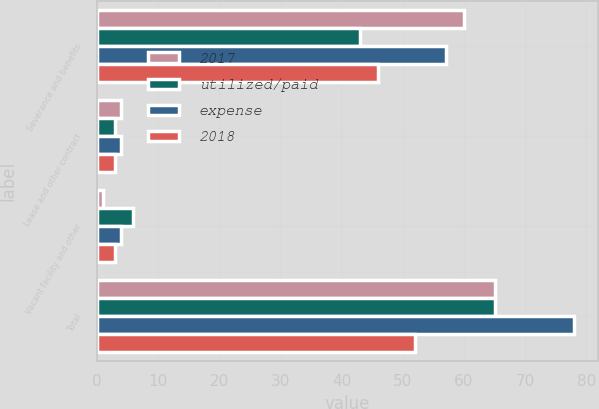<chart> <loc_0><loc_0><loc_500><loc_500><stacked_bar_chart><ecel><fcel>Severance and benefits<fcel>Lease and other contract<fcel>Vacant facility and other<fcel>Total<nl><fcel>2017<fcel>60<fcel>4<fcel>1<fcel>65<nl><fcel>utilized/paid<fcel>43<fcel>3<fcel>6<fcel>65<nl><fcel>expense<fcel>57<fcel>4<fcel>4<fcel>78<nl><fcel>2018<fcel>46<fcel>3<fcel>3<fcel>52<nl></chart> 